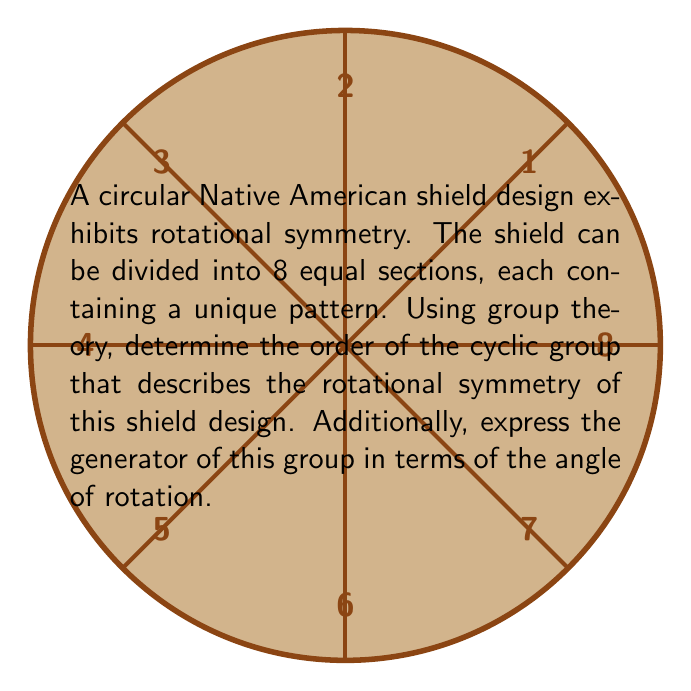Give your solution to this math problem. To solve this problem, we'll use concepts from group theory:

1) The rotational symmetry of the shield forms a cyclic group. The order of this group is equal to the number of distinct rotations that bring the shield back to its original position.

2) Given that the shield is divided into 8 equal sections, we can perform 8 distinct rotations:
   - 0° (identity)
   - 45°
   - 90°
   - 135°
   - 180°
   - 225°
   - 270°
   - 315°

3) Therefore, the order of the cyclic group is 8. We can denote this group as $C_8$ or $\mathbb{Z}_8$.

4) The generator of this group is the smallest non-identity rotation that, when repeated, generates all elements of the group. In this case, it's a rotation by 45°.

5) To express the generator in terms of the angle of rotation, we use the following notation:
   $r_{45°}$ or $r_{\frac{\pi}{4}}$ (in radians)

6) The group can be written as:
   $\{e, r_{45°}, r_{90°}, r_{135°}, r_{180°}, r_{225°}, r_{270°}, r_{315°}\}$
   where $e$ is the identity element (0° rotation).

7) In cyclic notation: $\langle r_{45°} \rangle = C_8$

This analysis demonstrates how group theory can be applied to understand and describe the symmetry patterns in Native American artwork, providing a mathematical framework for cultural preservation efforts.
Answer: Order: 8; Generator: $r_{45°}$ or $r_{\frac{\pi}{4}}$ 